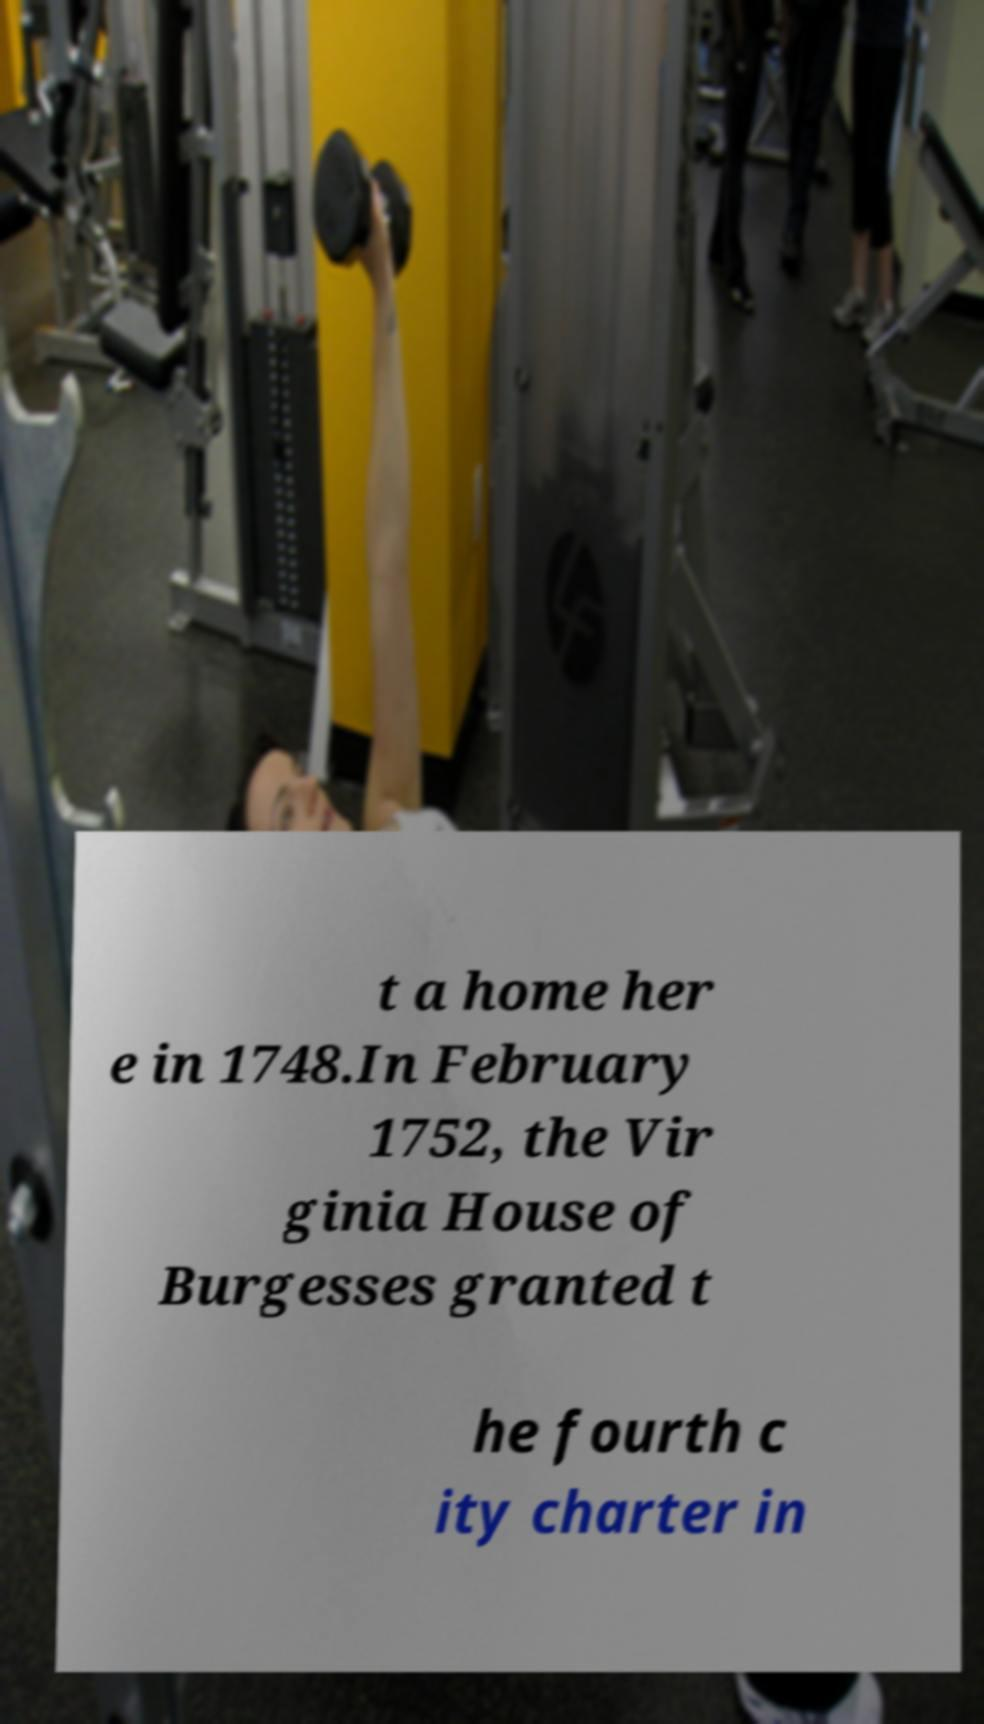Could you assist in decoding the text presented in this image and type it out clearly? t a home her e in 1748.In February 1752, the Vir ginia House of Burgesses granted t he fourth c ity charter in 